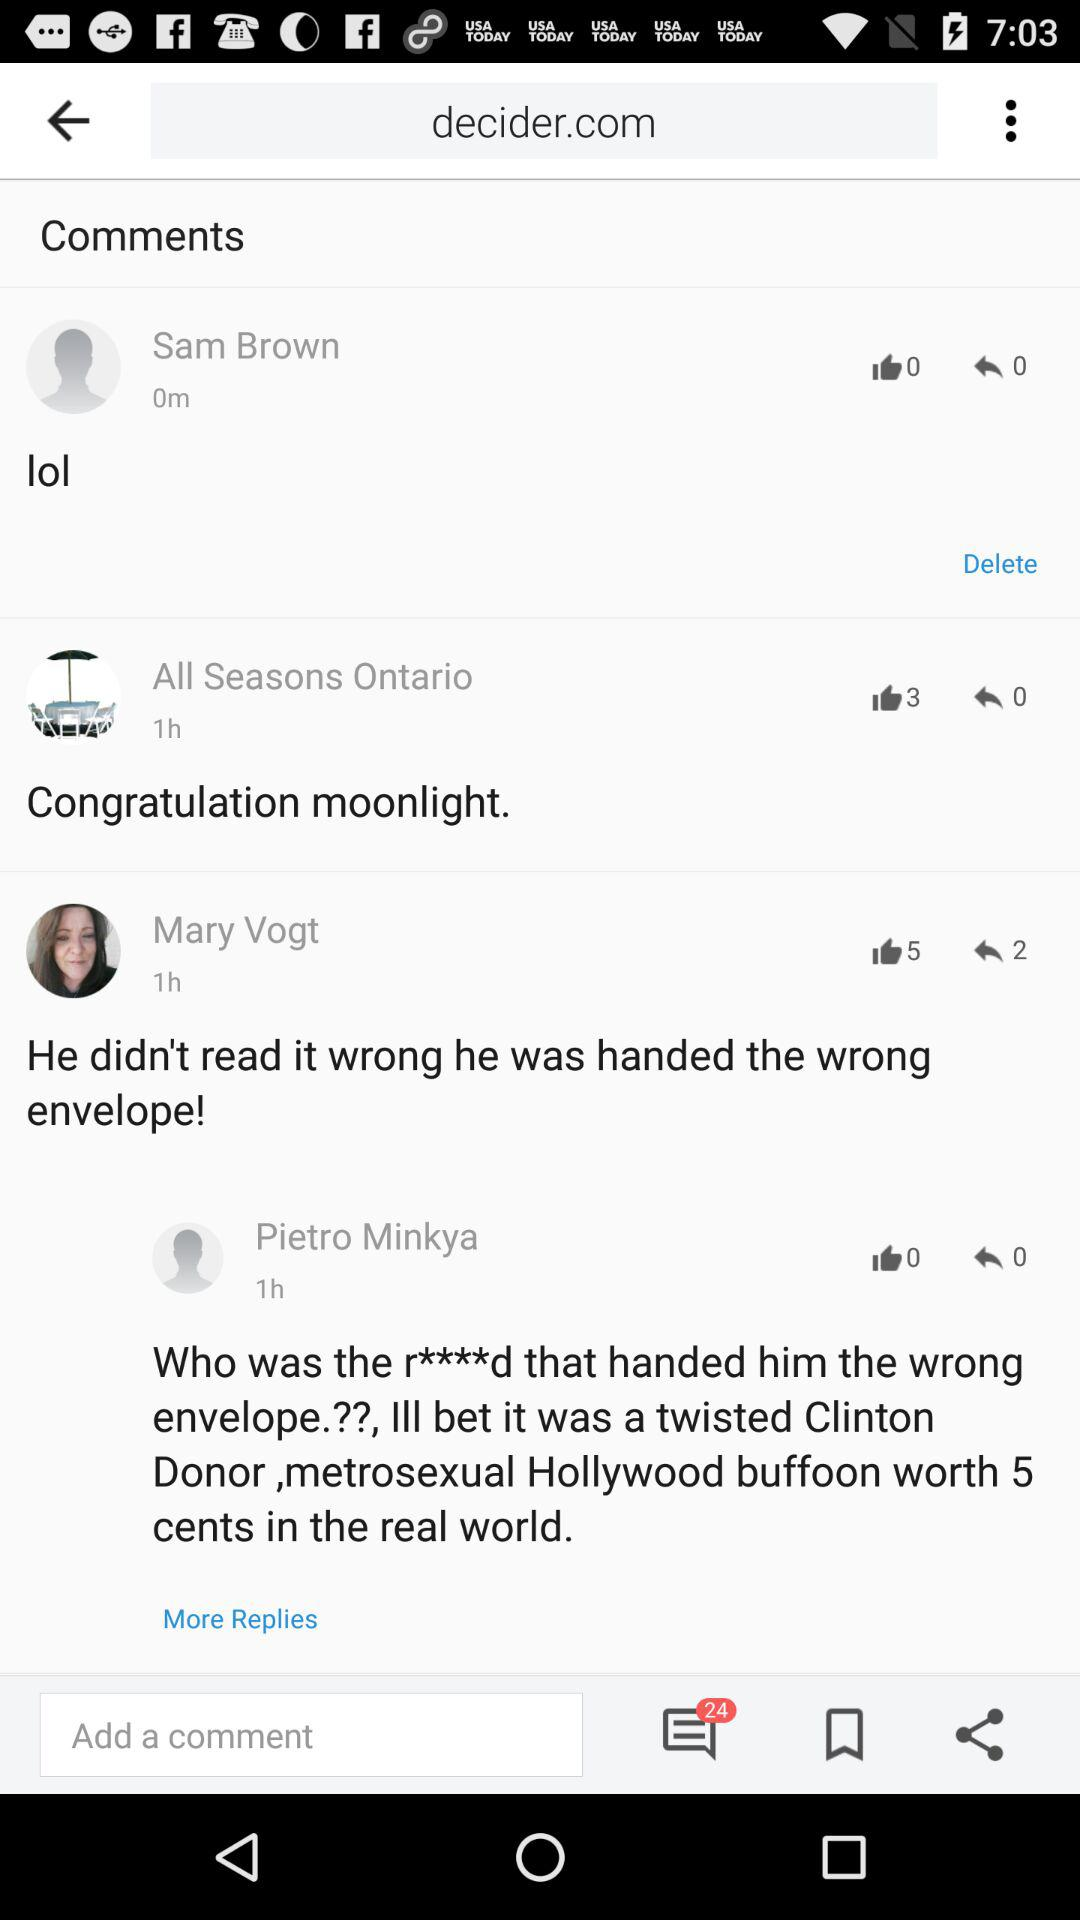How many likes are there on Mary Vogt's post? There are 5 likes on Mary Vogt's post. 